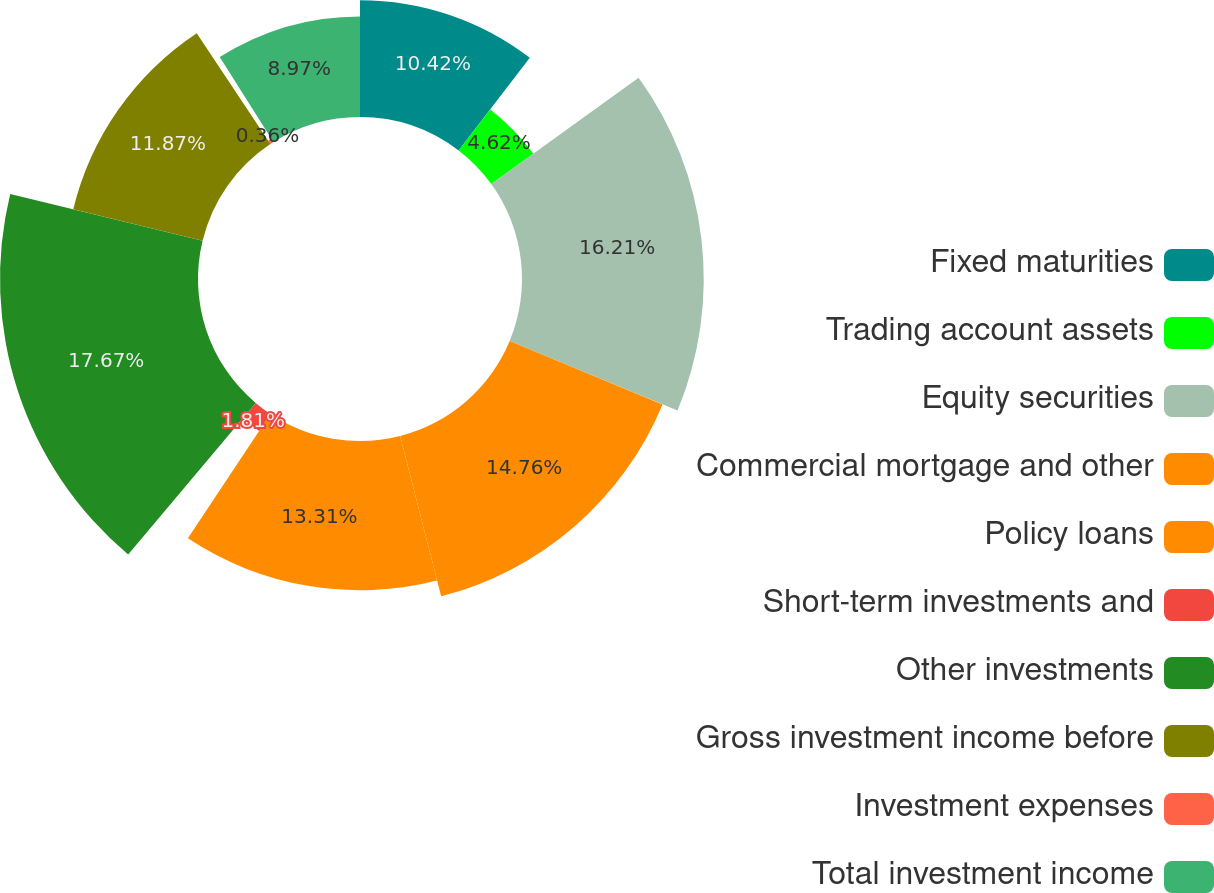<chart> <loc_0><loc_0><loc_500><loc_500><pie_chart><fcel>Fixed maturities<fcel>Trading account assets<fcel>Equity securities<fcel>Commercial mortgage and other<fcel>Policy loans<fcel>Short-term investments and<fcel>Other investments<fcel>Gross investment income before<fcel>Investment expenses<fcel>Total investment income<nl><fcel>10.42%<fcel>4.62%<fcel>16.21%<fcel>14.76%<fcel>13.31%<fcel>1.81%<fcel>17.66%<fcel>11.87%<fcel>0.36%<fcel>8.97%<nl></chart> 